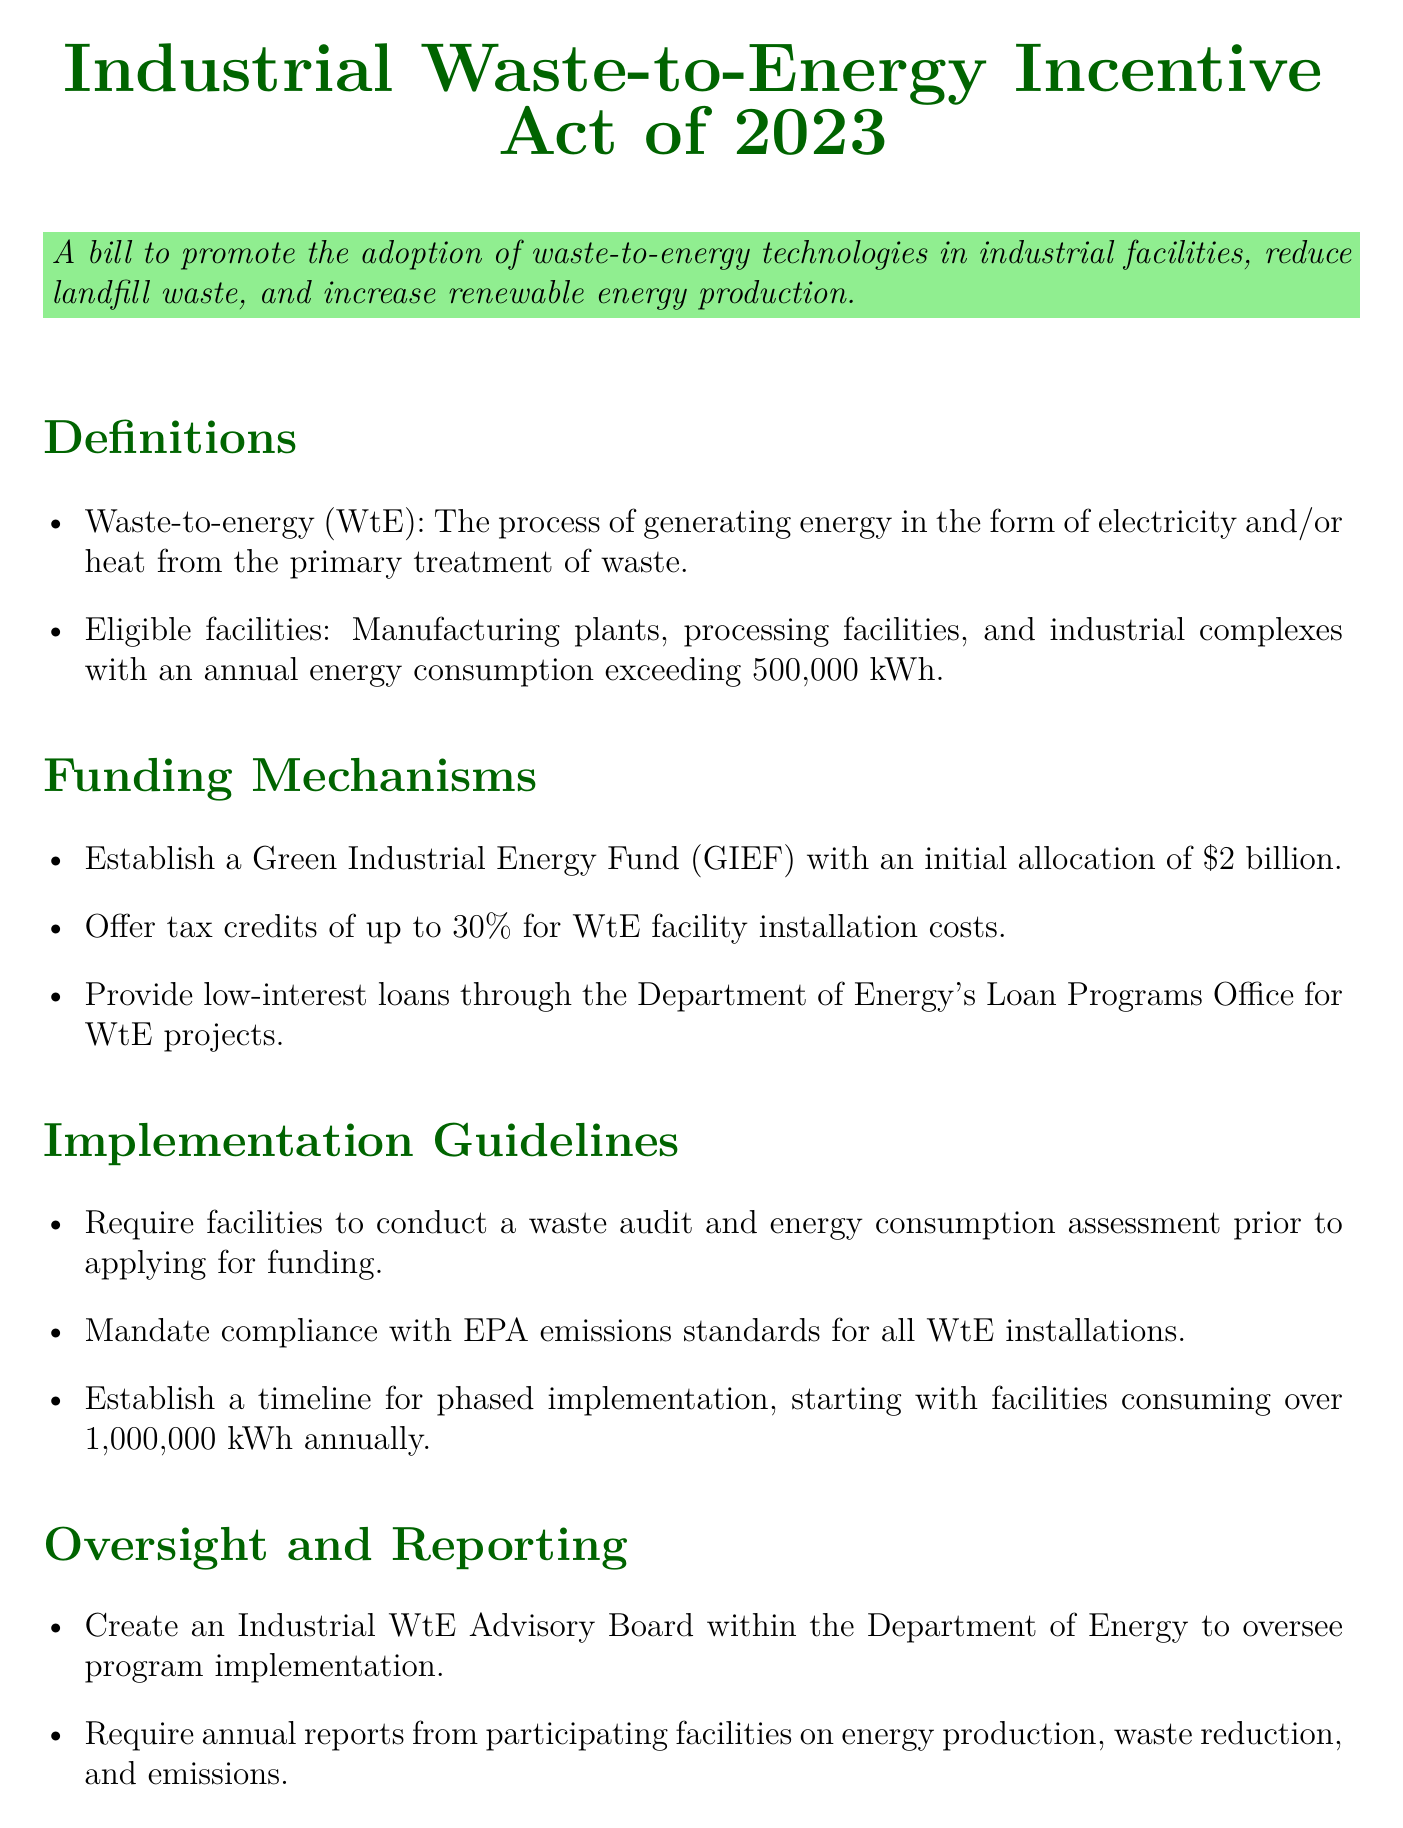What is the initial allocation of the Green Industrial Energy Fund? The document states that the initial allocation of the Green Industrial Energy Fund is $2 billion.
Answer: $2 billion What percentage of tax credits is offered for WtE facility installation costs? According to the funding mechanisms section, tax credits of up to 30% are offered.
Answer: 30% What is the annual energy consumption threshold for eligible facilities? The document specifies that eligible facilities must have an annual energy consumption exceeding 500,000 kWh.
Answer: 500,000 kWh Who is responsible for overseeing the program implementation? The document mentions the creation of an Industrial WtE Advisory Board within the Department of Energy to oversee program implementation.
Answer: Industrial WtE Advisory Board What is required from facilities before applying for funding? Facilities are required to conduct a waste audit and energy consumption assessment prior to applying for funding as stated in the implementation guidelines.
Answer: Waste audit and energy consumption assessment Which council is mentioned for technical expertise collaboration? The document names the Waste-to-Energy Research and Technology Council (WTERT) as a partner for technical expertise.
Answer: WTERT What type of loans are provided for WtE projects? The funding mechanisms section indicates that low-interest loans are available through the Department of Energy’s Loan Programs Office for WtE projects.
Answer: Low-interest loans What is one mandated compliance standard for WtE installations? The document requires compliance with EPA emissions standards for all WtE installations.
Answer: EPA emissions standards 